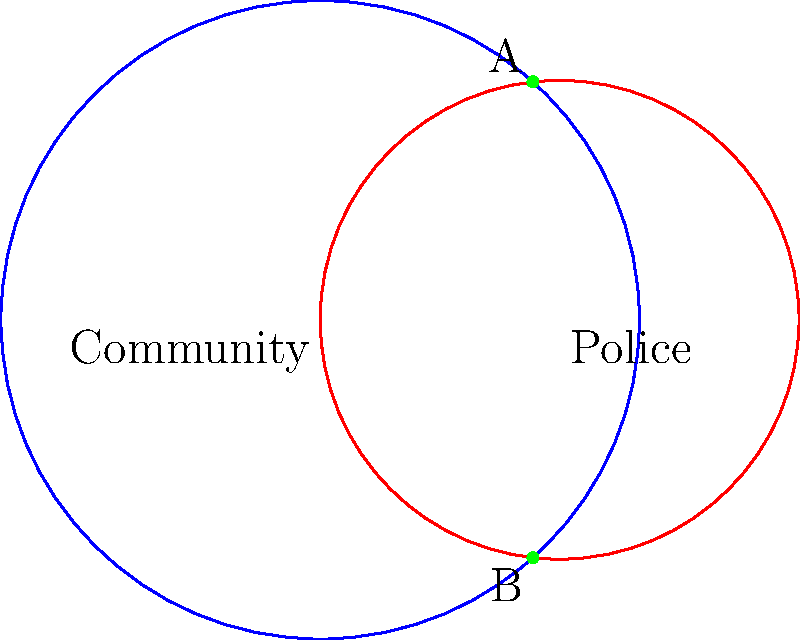Two circles representing overlapping community and police jurisdictions intersect at points A and B. The community jurisdiction has a radius of 4 units, while the police jurisdiction has a radius of 3 units. If the centers of the circles are 3 units apart, what is the area of the region where the jurisdictions overlap? To find the area of overlap between the two circles, we need to follow these steps:

1) First, we need to find the angle subtended by the chord AB at the center of each circle. Let's call these angles $\theta_1$ and $\theta_2$ for the community and police circles respectively.

2) We can find these angles using the cosine rule:

   For the community circle: $\cos(\frac{\theta_1}{2}) = \frac{3}{2\cdot4} = \frac{3}{8}$
   For the police circle: $\cos(\frac{\theta_2}{2}) = \frac{3}{2\cdot3} = \frac{1}{2}$

3) Therefore, $\theta_1 = 2\arccos(\frac{3}{8})$ and $\theta_2 = 2\arccos(\frac{1}{2})$

4) The area of overlap is the sum of two circular segments minus the area of the rhombus OABO':

   Area = (Sector area of community circle - Triangle area) + (Sector area of police circle - Triangle area)

5) Area of a sector is given by $\frac{r^2\theta}{2}$, where $r$ is the radius and $\theta$ is in radians.

6) Area of the triangle can be found using the formula $\frac{1}{2}ab\sin(C)$, where $a$ and $b$ are the radii and $C$ is the angle between them.

7) Putting it all together:

   Area = $\frac{4^2 \cdot 2\arccos(\frac{3}{8})}{2} + \frac{3^2 \cdot 2\arccos(\frac{1}{2})}{2} - 2 \cdot \frac{1}{2} \cdot 4 \cdot 3 \cdot \sin(\arccos(\frac{3}{8}))$

8) Simplifying:

   Area = $8\arccos(\frac{3}{8}) + \frac{9}{2}\arccos(\frac{1}{2}) - 6\sqrt{1-(\frac{3}{8})^2}$
Answer: $8\arccos(\frac{3}{8}) + \frac{9}{2}\arccos(\frac{1}{2}) - 6\sqrt{1-(\frac{3}{8})^2}$ square units 